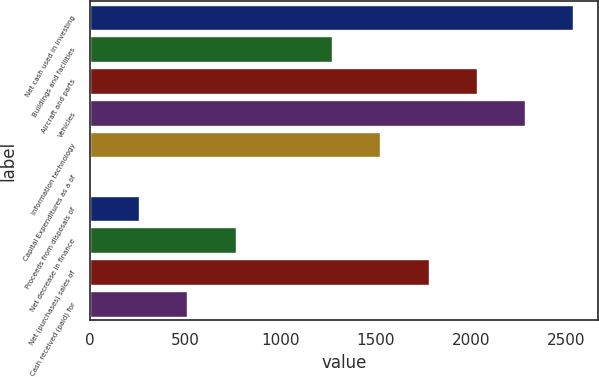Convert chart to OTSL. <chart><loc_0><loc_0><loc_500><loc_500><bar_chart><fcel>Net cash used in investing<fcel>Buildings and facilities<fcel>Aircraft and parts<fcel>Vehicles<fcel>Information technology<fcel>Capital Expenditures as a of<fcel>Proceeds from disposals of<fcel>Net decrease in finance<fcel>Net (purchases) sales of<fcel>Cash received (paid) for<nl><fcel>2537<fcel>1270.4<fcel>2030.36<fcel>2283.68<fcel>1523.72<fcel>3.8<fcel>257.12<fcel>763.76<fcel>1777.04<fcel>510.44<nl></chart> 